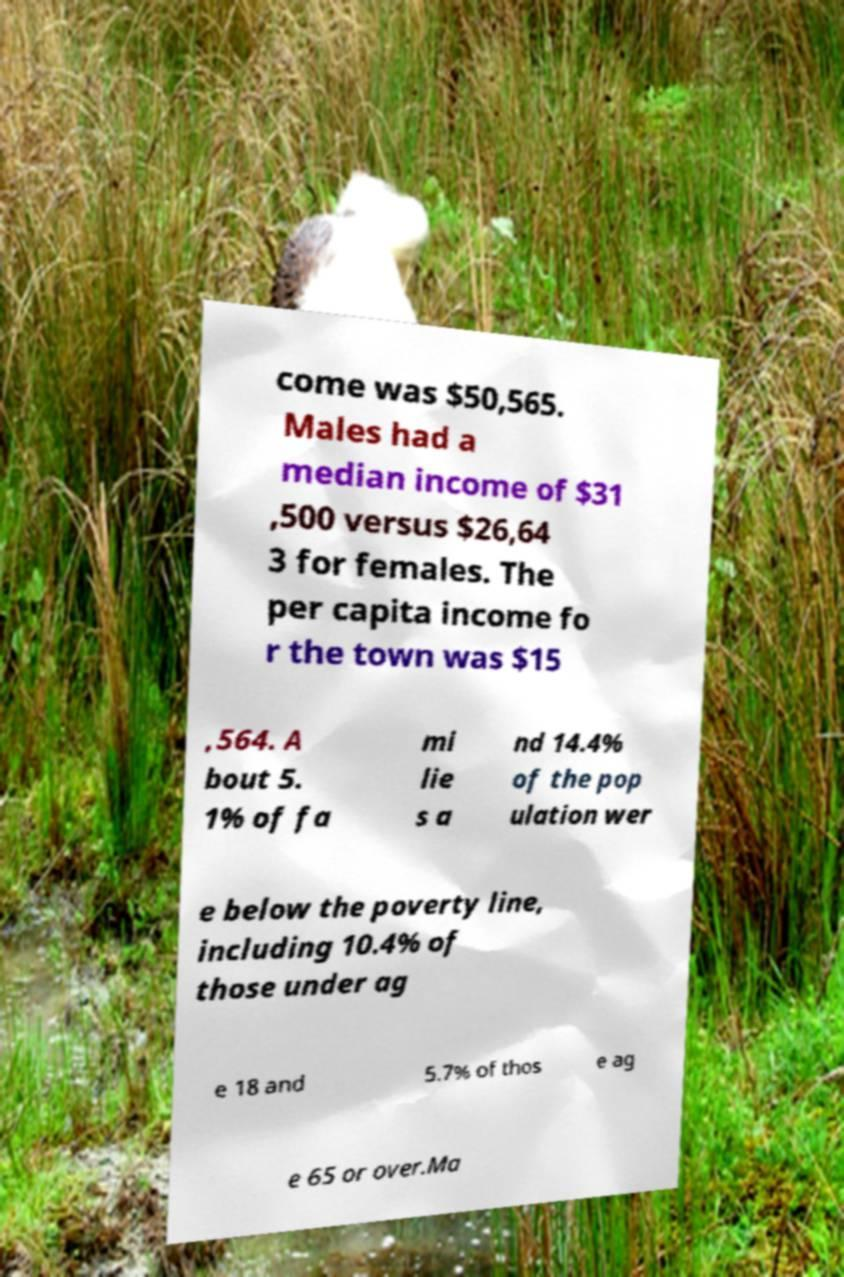Please read and relay the text visible in this image. What does it say? come was $50,565. Males had a median income of $31 ,500 versus $26,64 3 for females. The per capita income fo r the town was $15 ,564. A bout 5. 1% of fa mi lie s a nd 14.4% of the pop ulation wer e below the poverty line, including 10.4% of those under ag e 18 and 5.7% of thos e ag e 65 or over.Ma 